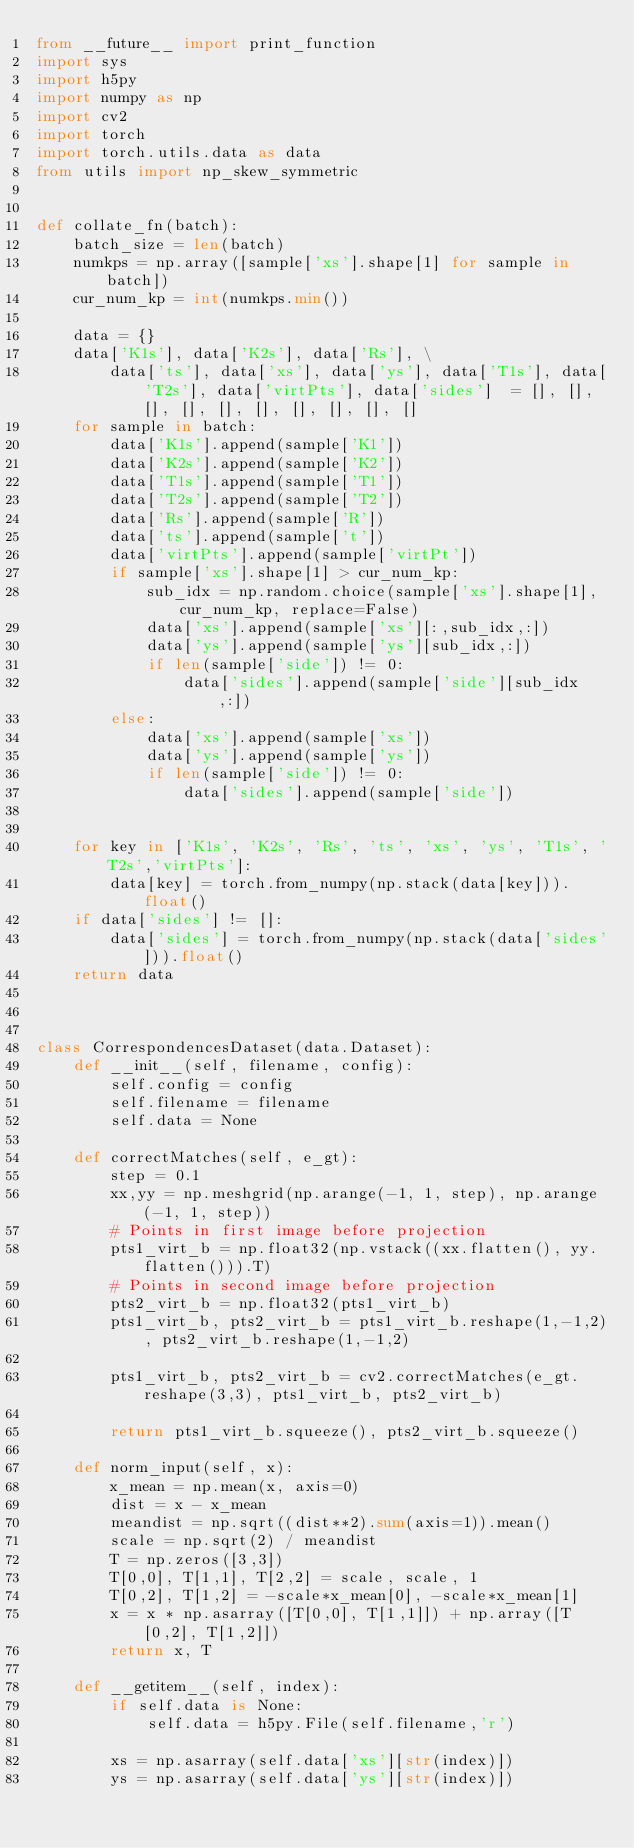<code> <loc_0><loc_0><loc_500><loc_500><_Python_>from __future__ import print_function
import sys
import h5py
import numpy as np
import cv2
import torch
import torch.utils.data as data
from utils import np_skew_symmetric


def collate_fn(batch):
    batch_size = len(batch)
    numkps = np.array([sample['xs'].shape[1] for sample in batch])
    cur_num_kp = int(numkps.min())

    data = {}
    data['K1s'], data['K2s'], data['Rs'], \
        data['ts'], data['xs'], data['ys'], data['T1s'], data['T2s'], data['virtPts'], data['sides']  = [], [], [], [], [], [], [], [], [], []
    for sample in batch:
        data['K1s'].append(sample['K1'])
        data['K2s'].append(sample['K2'])
        data['T1s'].append(sample['T1'])
        data['T2s'].append(sample['T2'])
        data['Rs'].append(sample['R'])
        data['ts'].append(sample['t'])
        data['virtPts'].append(sample['virtPt'])
        if sample['xs'].shape[1] > cur_num_kp:
            sub_idx = np.random.choice(sample['xs'].shape[1], cur_num_kp, replace=False)
            data['xs'].append(sample['xs'][:,sub_idx,:])
            data['ys'].append(sample['ys'][sub_idx,:])
            if len(sample['side']) != 0:
                data['sides'].append(sample['side'][sub_idx,:])
        else:
            data['xs'].append(sample['xs'])
            data['ys'].append(sample['ys'])
            if len(sample['side']) != 0:
                data['sides'].append(sample['side'])


    for key in ['K1s', 'K2s', 'Rs', 'ts', 'xs', 'ys', 'T1s', 'T2s','virtPts']:
        data[key] = torch.from_numpy(np.stack(data[key])).float()
    if data['sides'] != []:
        data['sides'] = torch.from_numpy(np.stack(data['sides'])).float()
    return data



class CorrespondencesDataset(data.Dataset):
    def __init__(self, filename, config):
        self.config = config
        self.filename = filename
        self.data = None

    def correctMatches(self, e_gt):
        step = 0.1
        xx,yy = np.meshgrid(np.arange(-1, 1, step), np.arange(-1, 1, step))
        # Points in first image before projection
        pts1_virt_b = np.float32(np.vstack((xx.flatten(), yy.flatten())).T)
        # Points in second image before projection
        pts2_virt_b = np.float32(pts1_virt_b)
        pts1_virt_b, pts2_virt_b = pts1_virt_b.reshape(1,-1,2), pts2_virt_b.reshape(1,-1,2)

        pts1_virt_b, pts2_virt_b = cv2.correctMatches(e_gt.reshape(3,3), pts1_virt_b, pts2_virt_b)

        return pts1_virt_b.squeeze(), pts2_virt_b.squeeze()

    def norm_input(self, x):
        x_mean = np.mean(x, axis=0)
        dist = x - x_mean
        meandist = np.sqrt((dist**2).sum(axis=1)).mean()
        scale = np.sqrt(2) / meandist
        T = np.zeros([3,3])
        T[0,0], T[1,1], T[2,2] = scale, scale, 1
        T[0,2], T[1,2] = -scale*x_mean[0], -scale*x_mean[1]
        x = x * np.asarray([T[0,0], T[1,1]]) + np.array([T[0,2], T[1,2]])
        return x, T
    
    def __getitem__(self, index):
        if self.data is None:
            self.data = h5py.File(self.filename,'r')

        xs = np.asarray(self.data['xs'][str(index)])
        ys = np.asarray(self.data['ys'][str(index)])</code> 